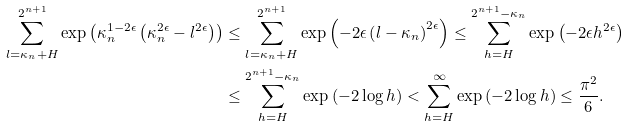<formula> <loc_0><loc_0><loc_500><loc_500>\sum _ { l = \kappa _ { n } + H } ^ { 2 ^ { n + 1 } } \exp \left ( \kappa _ { n } ^ { 1 - 2 \epsilon } \left ( \kappa _ { n } ^ { 2 \epsilon } - l ^ { 2 \epsilon } \right ) \right ) & \leq \sum _ { l = \kappa _ { n } + H } ^ { 2 ^ { n + 1 } } \exp \left ( - 2 \epsilon \left ( l - \kappa _ { n } \right ) ^ { 2 \epsilon } \right ) \leq \sum _ { h = H } ^ { 2 ^ { n + 1 } - \kappa _ { n } } \exp \left ( - 2 \epsilon h ^ { 2 \epsilon } \right ) \\ & \leq \sum _ { h = H } ^ { 2 ^ { n + 1 } - \kappa _ { n } } \exp \left ( - 2 \log h \right ) < \sum _ { h = H } ^ { \infty } \exp \left ( - 2 \log h \right ) \leq \frac { \pi ^ { 2 } } { 6 } .</formula> 